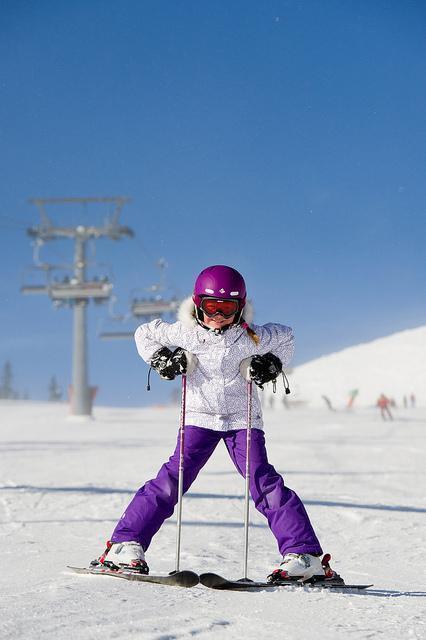What is the girl using the poles to do?
Select the accurate answer and provide explanation: 'Answer: answer
Rationale: rationale.'
Options: Stand up, climb, dig, reach. Answer: stand up.
Rationale: The girl wants to stand. 